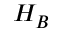<formula> <loc_0><loc_0><loc_500><loc_500>{ H } _ { B }</formula> 